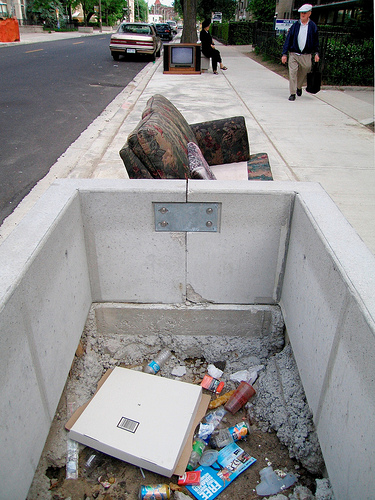<image>
Can you confirm if the sofa is above the pillow? No. The sofa is not positioned above the pillow. The vertical arrangement shows a different relationship. 